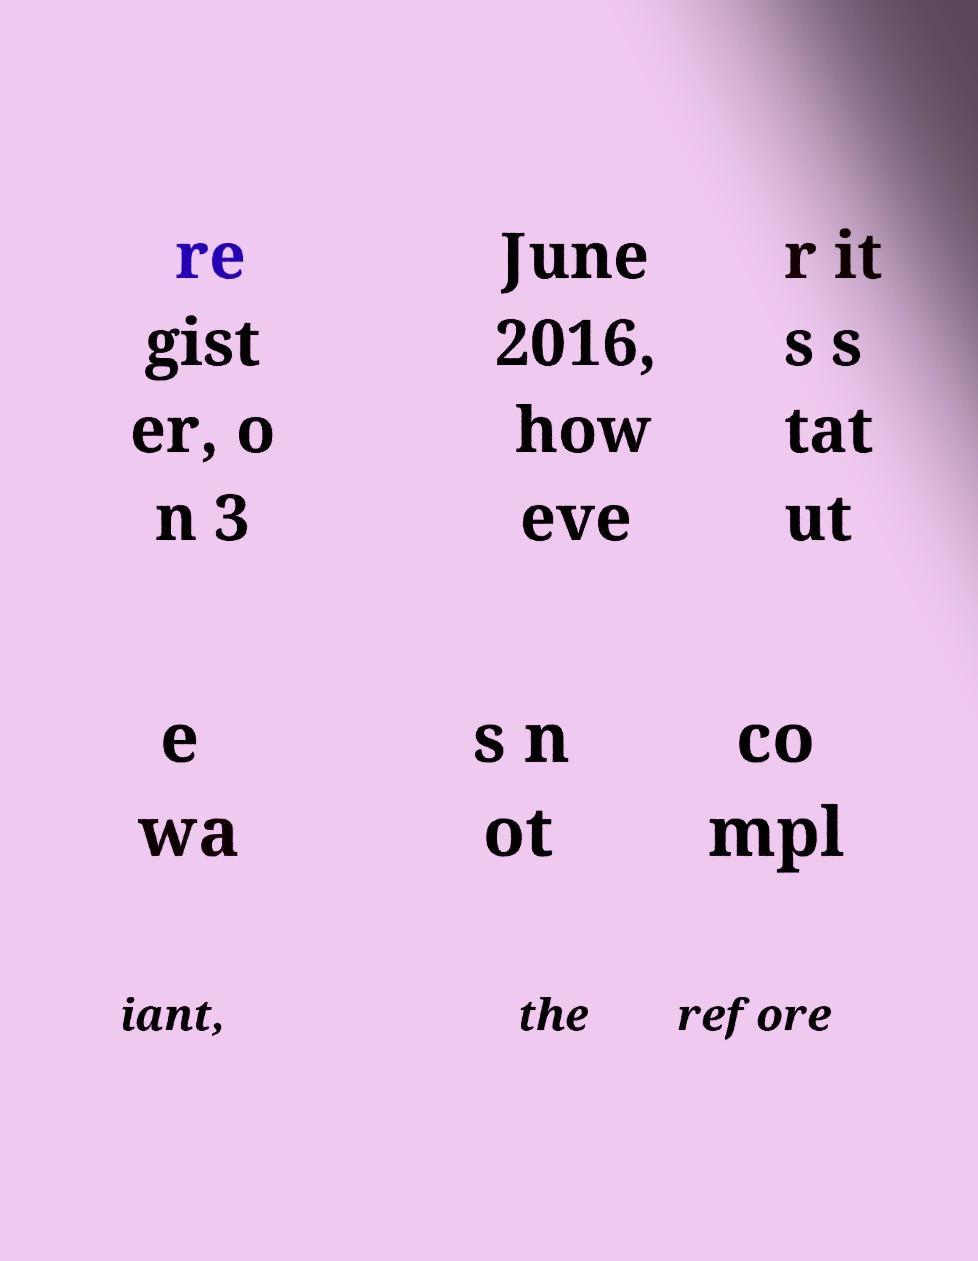Please identify and transcribe the text found in this image. re gist er, o n 3 June 2016, how eve r it s s tat ut e wa s n ot co mpl iant, the refore 